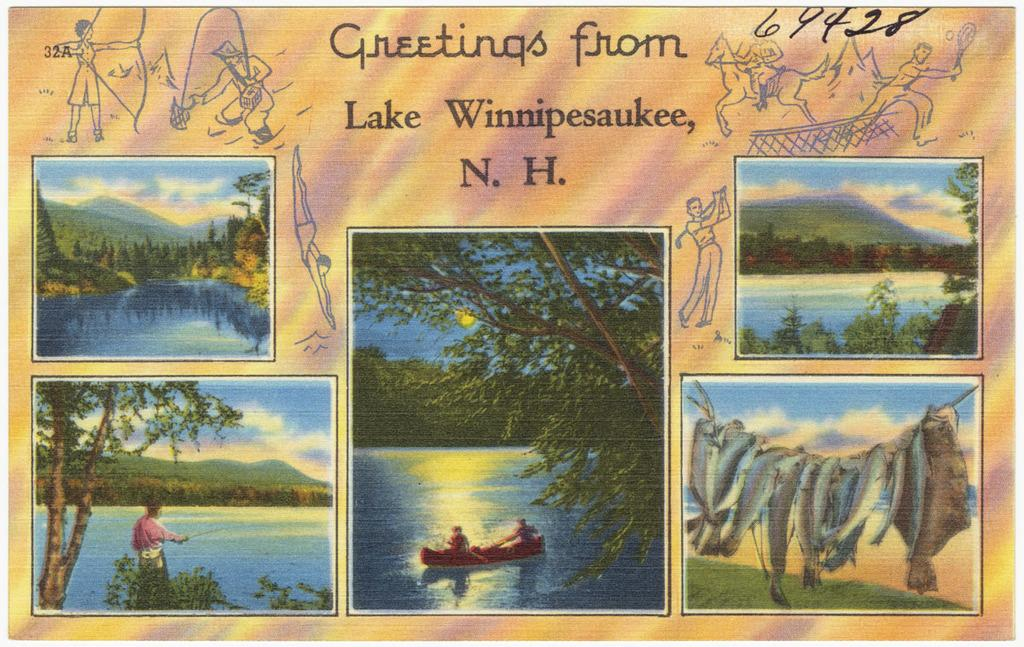What can be seen in the picture? There are images in the picture. What is present above the images? There is text written above the images. What type of floor is visible in the image? There is no floor visible in the image; it only contains images and text. 